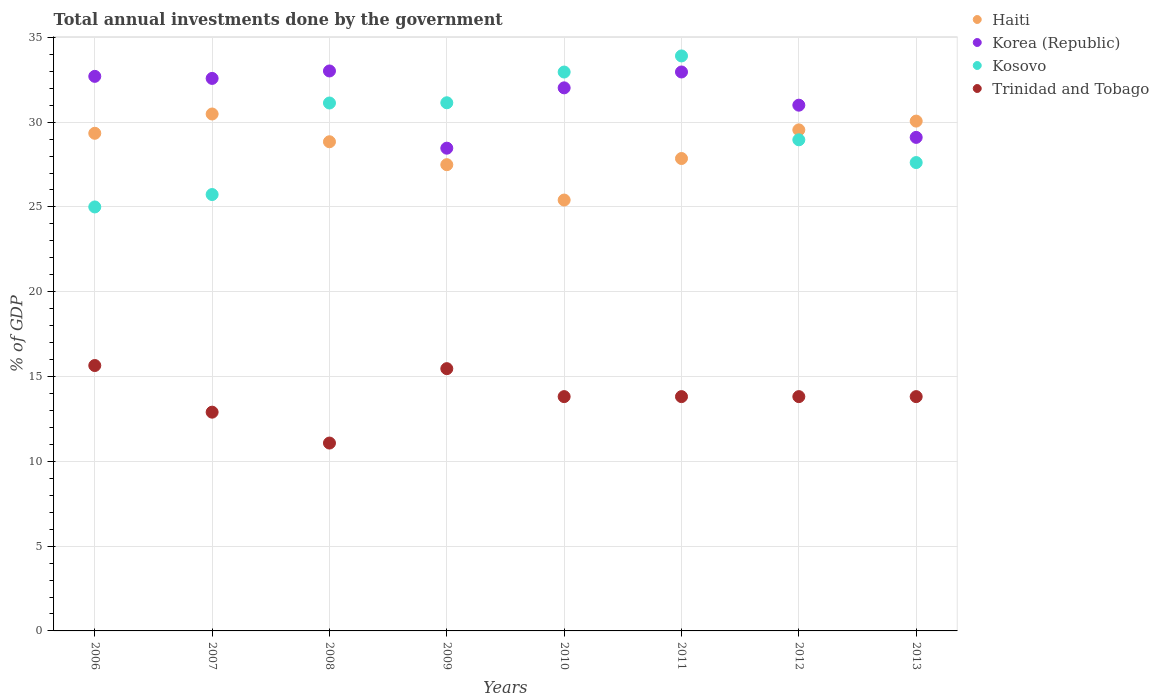Is the number of dotlines equal to the number of legend labels?
Keep it short and to the point. Yes. What is the total annual investments done by the government in Trinidad and Tobago in 2010?
Provide a succinct answer. 13.82. Across all years, what is the maximum total annual investments done by the government in Trinidad and Tobago?
Offer a terse response. 15.65. Across all years, what is the minimum total annual investments done by the government in Trinidad and Tobago?
Your response must be concise. 11.08. In which year was the total annual investments done by the government in Haiti maximum?
Provide a short and direct response. 2007. What is the total total annual investments done by the government in Korea (Republic) in the graph?
Keep it short and to the point. 251.85. What is the difference between the total annual investments done by the government in Trinidad and Tobago in 2010 and that in 2011?
Offer a very short reply. 0. What is the difference between the total annual investments done by the government in Haiti in 2006 and the total annual investments done by the government in Kosovo in 2012?
Make the answer very short. 0.38. What is the average total annual investments done by the government in Korea (Republic) per year?
Give a very brief answer. 31.48. In the year 2007, what is the difference between the total annual investments done by the government in Trinidad and Tobago and total annual investments done by the government in Kosovo?
Ensure brevity in your answer.  -12.83. In how many years, is the total annual investments done by the government in Korea (Republic) greater than 14 %?
Make the answer very short. 8. What is the ratio of the total annual investments done by the government in Korea (Republic) in 2006 to that in 2010?
Make the answer very short. 1.02. What is the difference between the highest and the second highest total annual investments done by the government in Haiti?
Ensure brevity in your answer.  0.42. What is the difference between the highest and the lowest total annual investments done by the government in Trinidad and Tobago?
Provide a succinct answer. 4.57. Does the total annual investments done by the government in Trinidad and Tobago monotonically increase over the years?
Keep it short and to the point. No. How many years are there in the graph?
Give a very brief answer. 8. What is the difference between two consecutive major ticks on the Y-axis?
Offer a very short reply. 5. Are the values on the major ticks of Y-axis written in scientific E-notation?
Offer a terse response. No. Does the graph contain any zero values?
Keep it short and to the point. No. Does the graph contain grids?
Keep it short and to the point. Yes. How many legend labels are there?
Keep it short and to the point. 4. What is the title of the graph?
Give a very brief answer. Total annual investments done by the government. What is the label or title of the Y-axis?
Offer a terse response. % of GDP. What is the % of GDP in Haiti in 2006?
Give a very brief answer. 29.34. What is the % of GDP of Korea (Republic) in 2006?
Ensure brevity in your answer.  32.7. What is the % of GDP in Kosovo in 2006?
Offer a very short reply. 25. What is the % of GDP in Trinidad and Tobago in 2006?
Keep it short and to the point. 15.65. What is the % of GDP in Haiti in 2007?
Make the answer very short. 30.48. What is the % of GDP in Korea (Republic) in 2007?
Provide a succinct answer. 32.58. What is the % of GDP in Kosovo in 2007?
Offer a terse response. 25.73. What is the % of GDP in Trinidad and Tobago in 2007?
Offer a very short reply. 12.9. What is the % of GDP of Haiti in 2008?
Your answer should be compact. 28.84. What is the % of GDP of Korea (Republic) in 2008?
Your answer should be compact. 33.02. What is the % of GDP of Kosovo in 2008?
Give a very brief answer. 31.13. What is the % of GDP in Trinidad and Tobago in 2008?
Provide a short and direct response. 11.08. What is the % of GDP in Haiti in 2009?
Ensure brevity in your answer.  27.49. What is the % of GDP of Korea (Republic) in 2009?
Your response must be concise. 28.47. What is the % of GDP of Kosovo in 2009?
Ensure brevity in your answer.  31.14. What is the % of GDP of Trinidad and Tobago in 2009?
Make the answer very short. 15.46. What is the % of GDP in Haiti in 2010?
Offer a very short reply. 25.41. What is the % of GDP in Korea (Republic) in 2010?
Your answer should be compact. 32.02. What is the % of GDP in Kosovo in 2010?
Offer a very short reply. 32.96. What is the % of GDP of Trinidad and Tobago in 2010?
Keep it short and to the point. 13.82. What is the % of GDP of Haiti in 2011?
Provide a succinct answer. 27.86. What is the % of GDP of Korea (Republic) in 2011?
Make the answer very short. 32.96. What is the % of GDP in Kosovo in 2011?
Give a very brief answer. 33.91. What is the % of GDP in Trinidad and Tobago in 2011?
Keep it short and to the point. 13.82. What is the % of GDP of Haiti in 2012?
Provide a short and direct response. 29.54. What is the % of GDP in Korea (Republic) in 2012?
Offer a terse response. 31. What is the % of GDP in Kosovo in 2012?
Provide a short and direct response. 28.96. What is the % of GDP of Trinidad and Tobago in 2012?
Keep it short and to the point. 13.82. What is the % of GDP in Haiti in 2013?
Ensure brevity in your answer.  30.06. What is the % of GDP of Korea (Republic) in 2013?
Your response must be concise. 29.1. What is the % of GDP in Kosovo in 2013?
Ensure brevity in your answer.  27.62. What is the % of GDP of Trinidad and Tobago in 2013?
Ensure brevity in your answer.  13.82. Across all years, what is the maximum % of GDP in Haiti?
Ensure brevity in your answer.  30.48. Across all years, what is the maximum % of GDP of Korea (Republic)?
Ensure brevity in your answer.  33.02. Across all years, what is the maximum % of GDP in Kosovo?
Your answer should be compact. 33.91. Across all years, what is the maximum % of GDP of Trinidad and Tobago?
Your response must be concise. 15.65. Across all years, what is the minimum % of GDP in Haiti?
Keep it short and to the point. 25.41. Across all years, what is the minimum % of GDP in Korea (Republic)?
Give a very brief answer. 28.47. Across all years, what is the minimum % of GDP in Kosovo?
Offer a terse response. 25. Across all years, what is the minimum % of GDP of Trinidad and Tobago?
Give a very brief answer. 11.08. What is the total % of GDP in Haiti in the graph?
Ensure brevity in your answer.  229.03. What is the total % of GDP of Korea (Republic) in the graph?
Your answer should be very brief. 251.85. What is the total % of GDP in Kosovo in the graph?
Your answer should be very brief. 236.44. What is the total % of GDP of Trinidad and Tobago in the graph?
Give a very brief answer. 110.36. What is the difference between the % of GDP of Haiti in 2006 and that in 2007?
Your answer should be very brief. -1.14. What is the difference between the % of GDP of Korea (Republic) in 2006 and that in 2007?
Your answer should be very brief. 0.12. What is the difference between the % of GDP in Kosovo in 2006 and that in 2007?
Your response must be concise. -0.73. What is the difference between the % of GDP of Trinidad and Tobago in 2006 and that in 2007?
Your answer should be compact. 2.75. What is the difference between the % of GDP of Haiti in 2006 and that in 2008?
Your response must be concise. 0.5. What is the difference between the % of GDP of Korea (Republic) in 2006 and that in 2008?
Offer a terse response. -0.32. What is the difference between the % of GDP of Kosovo in 2006 and that in 2008?
Give a very brief answer. -6.13. What is the difference between the % of GDP of Trinidad and Tobago in 2006 and that in 2008?
Offer a very short reply. 4.57. What is the difference between the % of GDP of Haiti in 2006 and that in 2009?
Keep it short and to the point. 1.85. What is the difference between the % of GDP of Korea (Republic) in 2006 and that in 2009?
Your answer should be compact. 4.24. What is the difference between the % of GDP in Kosovo in 2006 and that in 2009?
Provide a short and direct response. -6.14. What is the difference between the % of GDP in Trinidad and Tobago in 2006 and that in 2009?
Provide a succinct answer. 0.18. What is the difference between the % of GDP of Haiti in 2006 and that in 2010?
Your response must be concise. 3.94. What is the difference between the % of GDP in Korea (Republic) in 2006 and that in 2010?
Your answer should be compact. 0.68. What is the difference between the % of GDP of Kosovo in 2006 and that in 2010?
Your answer should be compact. -7.96. What is the difference between the % of GDP of Trinidad and Tobago in 2006 and that in 2010?
Offer a very short reply. 1.83. What is the difference between the % of GDP of Haiti in 2006 and that in 2011?
Keep it short and to the point. 1.49. What is the difference between the % of GDP in Korea (Republic) in 2006 and that in 2011?
Give a very brief answer. -0.26. What is the difference between the % of GDP of Kosovo in 2006 and that in 2011?
Ensure brevity in your answer.  -8.9. What is the difference between the % of GDP in Trinidad and Tobago in 2006 and that in 2011?
Offer a very short reply. 1.83. What is the difference between the % of GDP in Haiti in 2006 and that in 2012?
Keep it short and to the point. -0.2. What is the difference between the % of GDP of Korea (Republic) in 2006 and that in 2012?
Offer a terse response. 1.7. What is the difference between the % of GDP in Kosovo in 2006 and that in 2012?
Ensure brevity in your answer.  -3.96. What is the difference between the % of GDP in Trinidad and Tobago in 2006 and that in 2012?
Offer a terse response. 1.83. What is the difference between the % of GDP in Haiti in 2006 and that in 2013?
Keep it short and to the point. -0.72. What is the difference between the % of GDP in Korea (Republic) in 2006 and that in 2013?
Your answer should be very brief. 3.6. What is the difference between the % of GDP of Kosovo in 2006 and that in 2013?
Provide a succinct answer. -2.62. What is the difference between the % of GDP of Trinidad and Tobago in 2006 and that in 2013?
Ensure brevity in your answer.  1.83. What is the difference between the % of GDP of Haiti in 2007 and that in 2008?
Keep it short and to the point. 1.64. What is the difference between the % of GDP of Korea (Republic) in 2007 and that in 2008?
Make the answer very short. -0.44. What is the difference between the % of GDP of Kosovo in 2007 and that in 2008?
Give a very brief answer. -5.4. What is the difference between the % of GDP of Trinidad and Tobago in 2007 and that in 2008?
Keep it short and to the point. 1.82. What is the difference between the % of GDP of Haiti in 2007 and that in 2009?
Your answer should be compact. 2.99. What is the difference between the % of GDP in Korea (Republic) in 2007 and that in 2009?
Make the answer very short. 4.11. What is the difference between the % of GDP of Kosovo in 2007 and that in 2009?
Give a very brief answer. -5.41. What is the difference between the % of GDP in Trinidad and Tobago in 2007 and that in 2009?
Your answer should be compact. -2.57. What is the difference between the % of GDP of Haiti in 2007 and that in 2010?
Offer a terse response. 5.07. What is the difference between the % of GDP of Korea (Republic) in 2007 and that in 2010?
Provide a succinct answer. 0.56. What is the difference between the % of GDP in Kosovo in 2007 and that in 2010?
Offer a terse response. -7.22. What is the difference between the % of GDP of Trinidad and Tobago in 2007 and that in 2010?
Offer a terse response. -0.92. What is the difference between the % of GDP of Haiti in 2007 and that in 2011?
Give a very brief answer. 2.62. What is the difference between the % of GDP of Korea (Republic) in 2007 and that in 2011?
Offer a terse response. -0.38. What is the difference between the % of GDP of Kosovo in 2007 and that in 2011?
Make the answer very short. -8.17. What is the difference between the % of GDP of Trinidad and Tobago in 2007 and that in 2011?
Offer a very short reply. -0.92. What is the difference between the % of GDP of Haiti in 2007 and that in 2012?
Your answer should be very brief. 0.94. What is the difference between the % of GDP of Korea (Republic) in 2007 and that in 2012?
Ensure brevity in your answer.  1.58. What is the difference between the % of GDP in Kosovo in 2007 and that in 2012?
Offer a very short reply. -3.23. What is the difference between the % of GDP of Trinidad and Tobago in 2007 and that in 2012?
Offer a very short reply. -0.92. What is the difference between the % of GDP in Haiti in 2007 and that in 2013?
Your answer should be very brief. 0.42. What is the difference between the % of GDP in Korea (Republic) in 2007 and that in 2013?
Give a very brief answer. 3.48. What is the difference between the % of GDP of Kosovo in 2007 and that in 2013?
Provide a short and direct response. -1.89. What is the difference between the % of GDP of Trinidad and Tobago in 2007 and that in 2013?
Provide a short and direct response. -0.92. What is the difference between the % of GDP in Haiti in 2008 and that in 2009?
Provide a short and direct response. 1.35. What is the difference between the % of GDP in Korea (Republic) in 2008 and that in 2009?
Offer a very short reply. 4.55. What is the difference between the % of GDP in Kosovo in 2008 and that in 2009?
Provide a short and direct response. -0.01. What is the difference between the % of GDP of Trinidad and Tobago in 2008 and that in 2009?
Give a very brief answer. -4.39. What is the difference between the % of GDP in Haiti in 2008 and that in 2010?
Offer a very short reply. 3.44. What is the difference between the % of GDP in Kosovo in 2008 and that in 2010?
Provide a short and direct response. -1.83. What is the difference between the % of GDP in Trinidad and Tobago in 2008 and that in 2010?
Offer a very short reply. -2.74. What is the difference between the % of GDP of Haiti in 2008 and that in 2011?
Provide a succinct answer. 0.99. What is the difference between the % of GDP in Korea (Republic) in 2008 and that in 2011?
Your answer should be compact. 0.06. What is the difference between the % of GDP of Kosovo in 2008 and that in 2011?
Your response must be concise. -2.78. What is the difference between the % of GDP in Trinidad and Tobago in 2008 and that in 2011?
Your response must be concise. -2.74. What is the difference between the % of GDP in Haiti in 2008 and that in 2012?
Your answer should be very brief. -0.7. What is the difference between the % of GDP in Korea (Republic) in 2008 and that in 2012?
Your answer should be very brief. 2.02. What is the difference between the % of GDP in Kosovo in 2008 and that in 2012?
Make the answer very short. 2.17. What is the difference between the % of GDP of Trinidad and Tobago in 2008 and that in 2012?
Offer a terse response. -2.74. What is the difference between the % of GDP of Haiti in 2008 and that in 2013?
Offer a very short reply. -1.22. What is the difference between the % of GDP in Korea (Republic) in 2008 and that in 2013?
Provide a short and direct response. 3.92. What is the difference between the % of GDP of Kosovo in 2008 and that in 2013?
Provide a succinct answer. 3.51. What is the difference between the % of GDP of Trinidad and Tobago in 2008 and that in 2013?
Your answer should be compact. -2.74. What is the difference between the % of GDP of Haiti in 2009 and that in 2010?
Give a very brief answer. 2.09. What is the difference between the % of GDP of Korea (Republic) in 2009 and that in 2010?
Keep it short and to the point. -3.56. What is the difference between the % of GDP in Kosovo in 2009 and that in 2010?
Keep it short and to the point. -1.81. What is the difference between the % of GDP of Trinidad and Tobago in 2009 and that in 2010?
Your answer should be compact. 1.65. What is the difference between the % of GDP of Haiti in 2009 and that in 2011?
Your answer should be compact. -0.36. What is the difference between the % of GDP in Korea (Republic) in 2009 and that in 2011?
Provide a succinct answer. -4.49. What is the difference between the % of GDP in Kosovo in 2009 and that in 2011?
Provide a succinct answer. -2.76. What is the difference between the % of GDP of Trinidad and Tobago in 2009 and that in 2011?
Provide a succinct answer. 1.65. What is the difference between the % of GDP in Haiti in 2009 and that in 2012?
Give a very brief answer. -2.05. What is the difference between the % of GDP of Korea (Republic) in 2009 and that in 2012?
Ensure brevity in your answer.  -2.54. What is the difference between the % of GDP in Kosovo in 2009 and that in 2012?
Your response must be concise. 2.18. What is the difference between the % of GDP in Trinidad and Tobago in 2009 and that in 2012?
Make the answer very short. 1.65. What is the difference between the % of GDP of Haiti in 2009 and that in 2013?
Your response must be concise. -2.57. What is the difference between the % of GDP in Korea (Republic) in 2009 and that in 2013?
Provide a succinct answer. -0.64. What is the difference between the % of GDP of Kosovo in 2009 and that in 2013?
Give a very brief answer. 3.53. What is the difference between the % of GDP in Trinidad and Tobago in 2009 and that in 2013?
Give a very brief answer. 1.65. What is the difference between the % of GDP of Haiti in 2010 and that in 2011?
Provide a short and direct response. -2.45. What is the difference between the % of GDP in Korea (Republic) in 2010 and that in 2011?
Your response must be concise. -0.94. What is the difference between the % of GDP of Kosovo in 2010 and that in 2011?
Ensure brevity in your answer.  -0.95. What is the difference between the % of GDP of Trinidad and Tobago in 2010 and that in 2011?
Your answer should be very brief. 0. What is the difference between the % of GDP of Haiti in 2010 and that in 2012?
Provide a succinct answer. -4.14. What is the difference between the % of GDP in Korea (Republic) in 2010 and that in 2012?
Ensure brevity in your answer.  1.02. What is the difference between the % of GDP of Kosovo in 2010 and that in 2012?
Your response must be concise. 4. What is the difference between the % of GDP of Trinidad and Tobago in 2010 and that in 2012?
Make the answer very short. -0. What is the difference between the % of GDP of Haiti in 2010 and that in 2013?
Give a very brief answer. -4.66. What is the difference between the % of GDP of Korea (Republic) in 2010 and that in 2013?
Give a very brief answer. 2.92. What is the difference between the % of GDP in Kosovo in 2010 and that in 2013?
Provide a succinct answer. 5.34. What is the difference between the % of GDP of Haiti in 2011 and that in 2012?
Your answer should be very brief. -1.69. What is the difference between the % of GDP in Korea (Republic) in 2011 and that in 2012?
Make the answer very short. 1.96. What is the difference between the % of GDP in Kosovo in 2011 and that in 2012?
Provide a short and direct response. 4.95. What is the difference between the % of GDP of Trinidad and Tobago in 2011 and that in 2012?
Your answer should be compact. -0. What is the difference between the % of GDP in Haiti in 2011 and that in 2013?
Provide a succinct answer. -2.21. What is the difference between the % of GDP of Korea (Republic) in 2011 and that in 2013?
Offer a very short reply. 3.86. What is the difference between the % of GDP in Kosovo in 2011 and that in 2013?
Give a very brief answer. 6.29. What is the difference between the % of GDP in Trinidad and Tobago in 2011 and that in 2013?
Provide a succinct answer. -0. What is the difference between the % of GDP in Haiti in 2012 and that in 2013?
Keep it short and to the point. -0.52. What is the difference between the % of GDP of Korea (Republic) in 2012 and that in 2013?
Give a very brief answer. 1.9. What is the difference between the % of GDP in Kosovo in 2012 and that in 2013?
Your answer should be compact. 1.34. What is the difference between the % of GDP of Trinidad and Tobago in 2012 and that in 2013?
Your answer should be very brief. 0. What is the difference between the % of GDP of Haiti in 2006 and the % of GDP of Korea (Republic) in 2007?
Ensure brevity in your answer.  -3.24. What is the difference between the % of GDP of Haiti in 2006 and the % of GDP of Kosovo in 2007?
Ensure brevity in your answer.  3.61. What is the difference between the % of GDP of Haiti in 2006 and the % of GDP of Trinidad and Tobago in 2007?
Your answer should be very brief. 16.44. What is the difference between the % of GDP of Korea (Republic) in 2006 and the % of GDP of Kosovo in 2007?
Provide a short and direct response. 6.97. What is the difference between the % of GDP in Korea (Republic) in 2006 and the % of GDP in Trinidad and Tobago in 2007?
Offer a very short reply. 19.8. What is the difference between the % of GDP in Kosovo in 2006 and the % of GDP in Trinidad and Tobago in 2007?
Your answer should be compact. 12.1. What is the difference between the % of GDP of Haiti in 2006 and the % of GDP of Korea (Republic) in 2008?
Offer a terse response. -3.67. What is the difference between the % of GDP of Haiti in 2006 and the % of GDP of Kosovo in 2008?
Your answer should be compact. -1.79. What is the difference between the % of GDP in Haiti in 2006 and the % of GDP in Trinidad and Tobago in 2008?
Your answer should be very brief. 18.27. What is the difference between the % of GDP in Korea (Republic) in 2006 and the % of GDP in Kosovo in 2008?
Make the answer very short. 1.57. What is the difference between the % of GDP in Korea (Republic) in 2006 and the % of GDP in Trinidad and Tobago in 2008?
Offer a very short reply. 21.62. What is the difference between the % of GDP in Kosovo in 2006 and the % of GDP in Trinidad and Tobago in 2008?
Your answer should be compact. 13.92. What is the difference between the % of GDP of Haiti in 2006 and the % of GDP of Korea (Republic) in 2009?
Ensure brevity in your answer.  0.88. What is the difference between the % of GDP in Haiti in 2006 and the % of GDP in Kosovo in 2009?
Ensure brevity in your answer.  -1.8. What is the difference between the % of GDP in Haiti in 2006 and the % of GDP in Trinidad and Tobago in 2009?
Your response must be concise. 13.88. What is the difference between the % of GDP in Korea (Republic) in 2006 and the % of GDP in Kosovo in 2009?
Offer a terse response. 1.56. What is the difference between the % of GDP of Korea (Republic) in 2006 and the % of GDP of Trinidad and Tobago in 2009?
Make the answer very short. 17.24. What is the difference between the % of GDP in Kosovo in 2006 and the % of GDP in Trinidad and Tobago in 2009?
Ensure brevity in your answer.  9.54. What is the difference between the % of GDP of Haiti in 2006 and the % of GDP of Korea (Republic) in 2010?
Give a very brief answer. -2.68. What is the difference between the % of GDP of Haiti in 2006 and the % of GDP of Kosovo in 2010?
Keep it short and to the point. -3.61. What is the difference between the % of GDP in Haiti in 2006 and the % of GDP in Trinidad and Tobago in 2010?
Offer a very short reply. 15.53. What is the difference between the % of GDP in Korea (Republic) in 2006 and the % of GDP in Kosovo in 2010?
Make the answer very short. -0.26. What is the difference between the % of GDP of Korea (Republic) in 2006 and the % of GDP of Trinidad and Tobago in 2010?
Make the answer very short. 18.88. What is the difference between the % of GDP in Kosovo in 2006 and the % of GDP in Trinidad and Tobago in 2010?
Provide a short and direct response. 11.18. What is the difference between the % of GDP in Haiti in 2006 and the % of GDP in Korea (Republic) in 2011?
Keep it short and to the point. -3.62. What is the difference between the % of GDP in Haiti in 2006 and the % of GDP in Kosovo in 2011?
Give a very brief answer. -4.56. What is the difference between the % of GDP in Haiti in 2006 and the % of GDP in Trinidad and Tobago in 2011?
Offer a very short reply. 15.53. What is the difference between the % of GDP in Korea (Republic) in 2006 and the % of GDP in Kosovo in 2011?
Offer a terse response. -1.2. What is the difference between the % of GDP in Korea (Republic) in 2006 and the % of GDP in Trinidad and Tobago in 2011?
Make the answer very short. 18.88. What is the difference between the % of GDP of Kosovo in 2006 and the % of GDP of Trinidad and Tobago in 2011?
Your answer should be compact. 11.18. What is the difference between the % of GDP of Haiti in 2006 and the % of GDP of Korea (Republic) in 2012?
Provide a succinct answer. -1.66. What is the difference between the % of GDP of Haiti in 2006 and the % of GDP of Kosovo in 2012?
Your answer should be very brief. 0.38. What is the difference between the % of GDP of Haiti in 2006 and the % of GDP of Trinidad and Tobago in 2012?
Ensure brevity in your answer.  15.53. What is the difference between the % of GDP of Korea (Republic) in 2006 and the % of GDP of Kosovo in 2012?
Make the answer very short. 3.74. What is the difference between the % of GDP in Korea (Republic) in 2006 and the % of GDP in Trinidad and Tobago in 2012?
Your response must be concise. 18.88. What is the difference between the % of GDP of Kosovo in 2006 and the % of GDP of Trinidad and Tobago in 2012?
Provide a succinct answer. 11.18. What is the difference between the % of GDP of Haiti in 2006 and the % of GDP of Korea (Republic) in 2013?
Make the answer very short. 0.24. What is the difference between the % of GDP in Haiti in 2006 and the % of GDP in Kosovo in 2013?
Ensure brevity in your answer.  1.73. What is the difference between the % of GDP of Haiti in 2006 and the % of GDP of Trinidad and Tobago in 2013?
Give a very brief answer. 15.53. What is the difference between the % of GDP of Korea (Republic) in 2006 and the % of GDP of Kosovo in 2013?
Keep it short and to the point. 5.08. What is the difference between the % of GDP in Korea (Republic) in 2006 and the % of GDP in Trinidad and Tobago in 2013?
Make the answer very short. 18.88. What is the difference between the % of GDP in Kosovo in 2006 and the % of GDP in Trinidad and Tobago in 2013?
Make the answer very short. 11.18. What is the difference between the % of GDP in Haiti in 2007 and the % of GDP in Korea (Republic) in 2008?
Make the answer very short. -2.54. What is the difference between the % of GDP in Haiti in 2007 and the % of GDP in Kosovo in 2008?
Make the answer very short. -0.65. What is the difference between the % of GDP in Haiti in 2007 and the % of GDP in Trinidad and Tobago in 2008?
Provide a short and direct response. 19.4. What is the difference between the % of GDP in Korea (Republic) in 2007 and the % of GDP in Kosovo in 2008?
Make the answer very short. 1.45. What is the difference between the % of GDP in Korea (Republic) in 2007 and the % of GDP in Trinidad and Tobago in 2008?
Your answer should be compact. 21.5. What is the difference between the % of GDP of Kosovo in 2007 and the % of GDP of Trinidad and Tobago in 2008?
Your answer should be compact. 14.65. What is the difference between the % of GDP in Haiti in 2007 and the % of GDP in Korea (Republic) in 2009?
Offer a terse response. 2.02. What is the difference between the % of GDP of Haiti in 2007 and the % of GDP of Kosovo in 2009?
Offer a terse response. -0.66. What is the difference between the % of GDP of Haiti in 2007 and the % of GDP of Trinidad and Tobago in 2009?
Provide a succinct answer. 15.02. What is the difference between the % of GDP in Korea (Republic) in 2007 and the % of GDP in Kosovo in 2009?
Your answer should be compact. 1.44. What is the difference between the % of GDP of Korea (Republic) in 2007 and the % of GDP of Trinidad and Tobago in 2009?
Your answer should be very brief. 17.11. What is the difference between the % of GDP of Kosovo in 2007 and the % of GDP of Trinidad and Tobago in 2009?
Your response must be concise. 10.27. What is the difference between the % of GDP in Haiti in 2007 and the % of GDP in Korea (Republic) in 2010?
Ensure brevity in your answer.  -1.54. What is the difference between the % of GDP of Haiti in 2007 and the % of GDP of Kosovo in 2010?
Keep it short and to the point. -2.47. What is the difference between the % of GDP of Haiti in 2007 and the % of GDP of Trinidad and Tobago in 2010?
Your answer should be compact. 16.66. What is the difference between the % of GDP in Korea (Republic) in 2007 and the % of GDP in Kosovo in 2010?
Give a very brief answer. -0.38. What is the difference between the % of GDP of Korea (Republic) in 2007 and the % of GDP of Trinidad and Tobago in 2010?
Your answer should be very brief. 18.76. What is the difference between the % of GDP in Kosovo in 2007 and the % of GDP in Trinidad and Tobago in 2010?
Keep it short and to the point. 11.92. What is the difference between the % of GDP in Haiti in 2007 and the % of GDP in Korea (Republic) in 2011?
Offer a terse response. -2.48. What is the difference between the % of GDP in Haiti in 2007 and the % of GDP in Kosovo in 2011?
Your answer should be very brief. -3.42. What is the difference between the % of GDP in Haiti in 2007 and the % of GDP in Trinidad and Tobago in 2011?
Your response must be concise. 16.67. What is the difference between the % of GDP in Korea (Republic) in 2007 and the % of GDP in Kosovo in 2011?
Your response must be concise. -1.33. What is the difference between the % of GDP in Korea (Republic) in 2007 and the % of GDP in Trinidad and Tobago in 2011?
Your response must be concise. 18.76. What is the difference between the % of GDP in Kosovo in 2007 and the % of GDP in Trinidad and Tobago in 2011?
Your answer should be very brief. 11.92. What is the difference between the % of GDP in Haiti in 2007 and the % of GDP in Korea (Republic) in 2012?
Offer a very short reply. -0.52. What is the difference between the % of GDP of Haiti in 2007 and the % of GDP of Kosovo in 2012?
Provide a succinct answer. 1.52. What is the difference between the % of GDP in Haiti in 2007 and the % of GDP in Trinidad and Tobago in 2012?
Make the answer very short. 16.66. What is the difference between the % of GDP of Korea (Republic) in 2007 and the % of GDP of Kosovo in 2012?
Your answer should be very brief. 3.62. What is the difference between the % of GDP of Korea (Republic) in 2007 and the % of GDP of Trinidad and Tobago in 2012?
Make the answer very short. 18.76. What is the difference between the % of GDP in Kosovo in 2007 and the % of GDP in Trinidad and Tobago in 2012?
Provide a short and direct response. 11.92. What is the difference between the % of GDP of Haiti in 2007 and the % of GDP of Korea (Republic) in 2013?
Your response must be concise. 1.38. What is the difference between the % of GDP of Haiti in 2007 and the % of GDP of Kosovo in 2013?
Make the answer very short. 2.86. What is the difference between the % of GDP in Haiti in 2007 and the % of GDP in Trinidad and Tobago in 2013?
Provide a short and direct response. 16.67. What is the difference between the % of GDP of Korea (Republic) in 2007 and the % of GDP of Kosovo in 2013?
Keep it short and to the point. 4.96. What is the difference between the % of GDP in Korea (Republic) in 2007 and the % of GDP in Trinidad and Tobago in 2013?
Provide a short and direct response. 18.76. What is the difference between the % of GDP in Kosovo in 2007 and the % of GDP in Trinidad and Tobago in 2013?
Your answer should be compact. 11.92. What is the difference between the % of GDP in Haiti in 2008 and the % of GDP in Korea (Republic) in 2009?
Provide a short and direct response. 0.38. What is the difference between the % of GDP in Haiti in 2008 and the % of GDP in Kosovo in 2009?
Your answer should be compact. -2.3. What is the difference between the % of GDP of Haiti in 2008 and the % of GDP of Trinidad and Tobago in 2009?
Provide a succinct answer. 13.38. What is the difference between the % of GDP of Korea (Republic) in 2008 and the % of GDP of Kosovo in 2009?
Ensure brevity in your answer.  1.87. What is the difference between the % of GDP of Korea (Republic) in 2008 and the % of GDP of Trinidad and Tobago in 2009?
Provide a succinct answer. 17.55. What is the difference between the % of GDP of Kosovo in 2008 and the % of GDP of Trinidad and Tobago in 2009?
Make the answer very short. 15.66. What is the difference between the % of GDP of Haiti in 2008 and the % of GDP of Korea (Republic) in 2010?
Keep it short and to the point. -3.18. What is the difference between the % of GDP in Haiti in 2008 and the % of GDP in Kosovo in 2010?
Your answer should be very brief. -4.11. What is the difference between the % of GDP of Haiti in 2008 and the % of GDP of Trinidad and Tobago in 2010?
Your answer should be very brief. 15.03. What is the difference between the % of GDP of Korea (Republic) in 2008 and the % of GDP of Kosovo in 2010?
Offer a terse response. 0.06. What is the difference between the % of GDP in Korea (Republic) in 2008 and the % of GDP in Trinidad and Tobago in 2010?
Offer a very short reply. 19.2. What is the difference between the % of GDP of Kosovo in 2008 and the % of GDP of Trinidad and Tobago in 2010?
Your response must be concise. 17.31. What is the difference between the % of GDP in Haiti in 2008 and the % of GDP in Korea (Republic) in 2011?
Give a very brief answer. -4.11. What is the difference between the % of GDP of Haiti in 2008 and the % of GDP of Kosovo in 2011?
Keep it short and to the point. -5.06. What is the difference between the % of GDP of Haiti in 2008 and the % of GDP of Trinidad and Tobago in 2011?
Offer a very short reply. 15.03. What is the difference between the % of GDP in Korea (Republic) in 2008 and the % of GDP in Kosovo in 2011?
Keep it short and to the point. -0.89. What is the difference between the % of GDP in Korea (Republic) in 2008 and the % of GDP in Trinidad and Tobago in 2011?
Offer a very short reply. 19.2. What is the difference between the % of GDP in Kosovo in 2008 and the % of GDP in Trinidad and Tobago in 2011?
Give a very brief answer. 17.31. What is the difference between the % of GDP in Haiti in 2008 and the % of GDP in Korea (Republic) in 2012?
Your answer should be compact. -2.16. What is the difference between the % of GDP in Haiti in 2008 and the % of GDP in Kosovo in 2012?
Give a very brief answer. -0.11. What is the difference between the % of GDP in Haiti in 2008 and the % of GDP in Trinidad and Tobago in 2012?
Provide a short and direct response. 15.03. What is the difference between the % of GDP in Korea (Republic) in 2008 and the % of GDP in Kosovo in 2012?
Your answer should be very brief. 4.06. What is the difference between the % of GDP in Korea (Republic) in 2008 and the % of GDP in Trinidad and Tobago in 2012?
Provide a short and direct response. 19.2. What is the difference between the % of GDP of Kosovo in 2008 and the % of GDP of Trinidad and Tobago in 2012?
Your response must be concise. 17.31. What is the difference between the % of GDP of Haiti in 2008 and the % of GDP of Korea (Republic) in 2013?
Your answer should be compact. -0.26. What is the difference between the % of GDP of Haiti in 2008 and the % of GDP of Kosovo in 2013?
Ensure brevity in your answer.  1.23. What is the difference between the % of GDP in Haiti in 2008 and the % of GDP in Trinidad and Tobago in 2013?
Make the answer very short. 15.03. What is the difference between the % of GDP in Korea (Republic) in 2008 and the % of GDP in Kosovo in 2013?
Ensure brevity in your answer.  5.4. What is the difference between the % of GDP of Korea (Republic) in 2008 and the % of GDP of Trinidad and Tobago in 2013?
Offer a very short reply. 19.2. What is the difference between the % of GDP of Kosovo in 2008 and the % of GDP of Trinidad and Tobago in 2013?
Your response must be concise. 17.31. What is the difference between the % of GDP of Haiti in 2009 and the % of GDP of Korea (Republic) in 2010?
Your response must be concise. -4.53. What is the difference between the % of GDP of Haiti in 2009 and the % of GDP of Kosovo in 2010?
Keep it short and to the point. -5.46. What is the difference between the % of GDP in Haiti in 2009 and the % of GDP in Trinidad and Tobago in 2010?
Provide a short and direct response. 13.68. What is the difference between the % of GDP in Korea (Republic) in 2009 and the % of GDP in Kosovo in 2010?
Provide a succinct answer. -4.49. What is the difference between the % of GDP in Korea (Republic) in 2009 and the % of GDP in Trinidad and Tobago in 2010?
Provide a short and direct response. 14.65. What is the difference between the % of GDP of Kosovo in 2009 and the % of GDP of Trinidad and Tobago in 2010?
Ensure brevity in your answer.  17.33. What is the difference between the % of GDP in Haiti in 2009 and the % of GDP in Korea (Republic) in 2011?
Provide a succinct answer. -5.47. What is the difference between the % of GDP of Haiti in 2009 and the % of GDP of Kosovo in 2011?
Ensure brevity in your answer.  -6.41. What is the difference between the % of GDP in Haiti in 2009 and the % of GDP in Trinidad and Tobago in 2011?
Keep it short and to the point. 13.68. What is the difference between the % of GDP of Korea (Republic) in 2009 and the % of GDP of Kosovo in 2011?
Your answer should be compact. -5.44. What is the difference between the % of GDP of Korea (Republic) in 2009 and the % of GDP of Trinidad and Tobago in 2011?
Keep it short and to the point. 14.65. What is the difference between the % of GDP of Kosovo in 2009 and the % of GDP of Trinidad and Tobago in 2011?
Provide a short and direct response. 17.33. What is the difference between the % of GDP of Haiti in 2009 and the % of GDP of Korea (Republic) in 2012?
Provide a short and direct response. -3.51. What is the difference between the % of GDP of Haiti in 2009 and the % of GDP of Kosovo in 2012?
Keep it short and to the point. -1.47. What is the difference between the % of GDP in Haiti in 2009 and the % of GDP in Trinidad and Tobago in 2012?
Your answer should be compact. 13.68. What is the difference between the % of GDP in Korea (Republic) in 2009 and the % of GDP in Kosovo in 2012?
Your response must be concise. -0.49. What is the difference between the % of GDP of Korea (Republic) in 2009 and the % of GDP of Trinidad and Tobago in 2012?
Your answer should be very brief. 14.65. What is the difference between the % of GDP in Kosovo in 2009 and the % of GDP in Trinidad and Tobago in 2012?
Keep it short and to the point. 17.33. What is the difference between the % of GDP of Haiti in 2009 and the % of GDP of Korea (Republic) in 2013?
Provide a succinct answer. -1.61. What is the difference between the % of GDP of Haiti in 2009 and the % of GDP of Kosovo in 2013?
Keep it short and to the point. -0.13. What is the difference between the % of GDP of Haiti in 2009 and the % of GDP of Trinidad and Tobago in 2013?
Make the answer very short. 13.68. What is the difference between the % of GDP in Korea (Republic) in 2009 and the % of GDP in Kosovo in 2013?
Give a very brief answer. 0.85. What is the difference between the % of GDP of Korea (Republic) in 2009 and the % of GDP of Trinidad and Tobago in 2013?
Give a very brief answer. 14.65. What is the difference between the % of GDP of Kosovo in 2009 and the % of GDP of Trinidad and Tobago in 2013?
Provide a short and direct response. 17.33. What is the difference between the % of GDP in Haiti in 2010 and the % of GDP in Korea (Republic) in 2011?
Give a very brief answer. -7.55. What is the difference between the % of GDP in Haiti in 2010 and the % of GDP in Kosovo in 2011?
Ensure brevity in your answer.  -8.5. What is the difference between the % of GDP of Haiti in 2010 and the % of GDP of Trinidad and Tobago in 2011?
Ensure brevity in your answer.  11.59. What is the difference between the % of GDP of Korea (Republic) in 2010 and the % of GDP of Kosovo in 2011?
Offer a very short reply. -1.88. What is the difference between the % of GDP in Korea (Republic) in 2010 and the % of GDP in Trinidad and Tobago in 2011?
Offer a very short reply. 18.21. What is the difference between the % of GDP in Kosovo in 2010 and the % of GDP in Trinidad and Tobago in 2011?
Offer a very short reply. 19.14. What is the difference between the % of GDP in Haiti in 2010 and the % of GDP in Korea (Republic) in 2012?
Give a very brief answer. -5.59. What is the difference between the % of GDP of Haiti in 2010 and the % of GDP of Kosovo in 2012?
Make the answer very short. -3.55. What is the difference between the % of GDP in Haiti in 2010 and the % of GDP in Trinidad and Tobago in 2012?
Keep it short and to the point. 11.59. What is the difference between the % of GDP of Korea (Republic) in 2010 and the % of GDP of Kosovo in 2012?
Offer a very short reply. 3.06. What is the difference between the % of GDP of Korea (Republic) in 2010 and the % of GDP of Trinidad and Tobago in 2012?
Offer a terse response. 18.21. What is the difference between the % of GDP of Kosovo in 2010 and the % of GDP of Trinidad and Tobago in 2012?
Your response must be concise. 19.14. What is the difference between the % of GDP of Haiti in 2010 and the % of GDP of Korea (Republic) in 2013?
Provide a short and direct response. -3.69. What is the difference between the % of GDP in Haiti in 2010 and the % of GDP in Kosovo in 2013?
Give a very brief answer. -2.21. What is the difference between the % of GDP of Haiti in 2010 and the % of GDP of Trinidad and Tobago in 2013?
Your answer should be compact. 11.59. What is the difference between the % of GDP in Korea (Republic) in 2010 and the % of GDP in Kosovo in 2013?
Your answer should be compact. 4.41. What is the difference between the % of GDP in Korea (Republic) in 2010 and the % of GDP in Trinidad and Tobago in 2013?
Give a very brief answer. 18.21. What is the difference between the % of GDP in Kosovo in 2010 and the % of GDP in Trinidad and Tobago in 2013?
Make the answer very short. 19.14. What is the difference between the % of GDP of Haiti in 2011 and the % of GDP of Korea (Republic) in 2012?
Offer a very short reply. -3.14. What is the difference between the % of GDP of Haiti in 2011 and the % of GDP of Kosovo in 2012?
Ensure brevity in your answer.  -1.1. What is the difference between the % of GDP of Haiti in 2011 and the % of GDP of Trinidad and Tobago in 2012?
Make the answer very short. 14.04. What is the difference between the % of GDP of Korea (Republic) in 2011 and the % of GDP of Kosovo in 2012?
Your answer should be compact. 4. What is the difference between the % of GDP in Korea (Republic) in 2011 and the % of GDP in Trinidad and Tobago in 2012?
Make the answer very short. 19.14. What is the difference between the % of GDP in Kosovo in 2011 and the % of GDP in Trinidad and Tobago in 2012?
Ensure brevity in your answer.  20.09. What is the difference between the % of GDP in Haiti in 2011 and the % of GDP in Korea (Republic) in 2013?
Your answer should be compact. -1.25. What is the difference between the % of GDP of Haiti in 2011 and the % of GDP of Kosovo in 2013?
Ensure brevity in your answer.  0.24. What is the difference between the % of GDP in Haiti in 2011 and the % of GDP in Trinidad and Tobago in 2013?
Your response must be concise. 14.04. What is the difference between the % of GDP in Korea (Republic) in 2011 and the % of GDP in Kosovo in 2013?
Ensure brevity in your answer.  5.34. What is the difference between the % of GDP in Korea (Republic) in 2011 and the % of GDP in Trinidad and Tobago in 2013?
Offer a very short reply. 19.14. What is the difference between the % of GDP in Kosovo in 2011 and the % of GDP in Trinidad and Tobago in 2013?
Offer a very short reply. 20.09. What is the difference between the % of GDP of Haiti in 2012 and the % of GDP of Korea (Republic) in 2013?
Keep it short and to the point. 0.44. What is the difference between the % of GDP in Haiti in 2012 and the % of GDP in Kosovo in 2013?
Make the answer very short. 1.93. What is the difference between the % of GDP in Haiti in 2012 and the % of GDP in Trinidad and Tobago in 2013?
Your answer should be compact. 15.73. What is the difference between the % of GDP in Korea (Republic) in 2012 and the % of GDP in Kosovo in 2013?
Make the answer very short. 3.38. What is the difference between the % of GDP in Korea (Republic) in 2012 and the % of GDP in Trinidad and Tobago in 2013?
Your answer should be very brief. 17.19. What is the difference between the % of GDP of Kosovo in 2012 and the % of GDP of Trinidad and Tobago in 2013?
Your answer should be compact. 15.14. What is the average % of GDP of Haiti per year?
Provide a short and direct response. 28.63. What is the average % of GDP in Korea (Republic) per year?
Offer a very short reply. 31.48. What is the average % of GDP of Kosovo per year?
Make the answer very short. 29.56. What is the average % of GDP in Trinidad and Tobago per year?
Make the answer very short. 13.79. In the year 2006, what is the difference between the % of GDP of Haiti and % of GDP of Korea (Republic)?
Your answer should be very brief. -3.36. In the year 2006, what is the difference between the % of GDP in Haiti and % of GDP in Kosovo?
Your response must be concise. 4.34. In the year 2006, what is the difference between the % of GDP in Haiti and % of GDP in Trinidad and Tobago?
Offer a terse response. 13.69. In the year 2006, what is the difference between the % of GDP in Korea (Republic) and % of GDP in Kosovo?
Your answer should be very brief. 7.7. In the year 2006, what is the difference between the % of GDP in Korea (Republic) and % of GDP in Trinidad and Tobago?
Your answer should be very brief. 17.05. In the year 2006, what is the difference between the % of GDP of Kosovo and % of GDP of Trinidad and Tobago?
Your answer should be compact. 9.35. In the year 2007, what is the difference between the % of GDP in Haiti and % of GDP in Korea (Republic)?
Make the answer very short. -2.1. In the year 2007, what is the difference between the % of GDP in Haiti and % of GDP in Kosovo?
Your answer should be compact. 4.75. In the year 2007, what is the difference between the % of GDP of Haiti and % of GDP of Trinidad and Tobago?
Your answer should be very brief. 17.58. In the year 2007, what is the difference between the % of GDP in Korea (Republic) and % of GDP in Kosovo?
Your answer should be compact. 6.85. In the year 2007, what is the difference between the % of GDP of Korea (Republic) and % of GDP of Trinidad and Tobago?
Your response must be concise. 19.68. In the year 2007, what is the difference between the % of GDP in Kosovo and % of GDP in Trinidad and Tobago?
Make the answer very short. 12.83. In the year 2008, what is the difference between the % of GDP of Haiti and % of GDP of Korea (Republic)?
Make the answer very short. -4.17. In the year 2008, what is the difference between the % of GDP of Haiti and % of GDP of Kosovo?
Give a very brief answer. -2.29. In the year 2008, what is the difference between the % of GDP in Haiti and % of GDP in Trinidad and Tobago?
Provide a succinct answer. 17.77. In the year 2008, what is the difference between the % of GDP in Korea (Republic) and % of GDP in Kosovo?
Provide a short and direct response. 1.89. In the year 2008, what is the difference between the % of GDP in Korea (Republic) and % of GDP in Trinidad and Tobago?
Your answer should be very brief. 21.94. In the year 2008, what is the difference between the % of GDP in Kosovo and % of GDP in Trinidad and Tobago?
Provide a short and direct response. 20.05. In the year 2009, what is the difference between the % of GDP of Haiti and % of GDP of Korea (Republic)?
Keep it short and to the point. -0.97. In the year 2009, what is the difference between the % of GDP of Haiti and % of GDP of Kosovo?
Your answer should be compact. -3.65. In the year 2009, what is the difference between the % of GDP of Haiti and % of GDP of Trinidad and Tobago?
Offer a very short reply. 12.03. In the year 2009, what is the difference between the % of GDP of Korea (Republic) and % of GDP of Kosovo?
Ensure brevity in your answer.  -2.68. In the year 2009, what is the difference between the % of GDP in Korea (Republic) and % of GDP in Trinidad and Tobago?
Your answer should be very brief. 13. In the year 2009, what is the difference between the % of GDP in Kosovo and % of GDP in Trinidad and Tobago?
Offer a terse response. 15.68. In the year 2010, what is the difference between the % of GDP in Haiti and % of GDP in Korea (Republic)?
Offer a very short reply. -6.62. In the year 2010, what is the difference between the % of GDP of Haiti and % of GDP of Kosovo?
Give a very brief answer. -7.55. In the year 2010, what is the difference between the % of GDP of Haiti and % of GDP of Trinidad and Tobago?
Your answer should be compact. 11.59. In the year 2010, what is the difference between the % of GDP in Korea (Republic) and % of GDP in Kosovo?
Offer a very short reply. -0.93. In the year 2010, what is the difference between the % of GDP of Korea (Republic) and % of GDP of Trinidad and Tobago?
Offer a terse response. 18.21. In the year 2010, what is the difference between the % of GDP in Kosovo and % of GDP in Trinidad and Tobago?
Your answer should be compact. 19.14. In the year 2011, what is the difference between the % of GDP of Haiti and % of GDP of Korea (Republic)?
Provide a succinct answer. -5.1. In the year 2011, what is the difference between the % of GDP of Haiti and % of GDP of Kosovo?
Offer a terse response. -6.05. In the year 2011, what is the difference between the % of GDP of Haiti and % of GDP of Trinidad and Tobago?
Your response must be concise. 14.04. In the year 2011, what is the difference between the % of GDP of Korea (Republic) and % of GDP of Kosovo?
Give a very brief answer. -0.95. In the year 2011, what is the difference between the % of GDP of Korea (Republic) and % of GDP of Trinidad and Tobago?
Keep it short and to the point. 19.14. In the year 2011, what is the difference between the % of GDP of Kosovo and % of GDP of Trinidad and Tobago?
Your response must be concise. 20.09. In the year 2012, what is the difference between the % of GDP of Haiti and % of GDP of Korea (Republic)?
Offer a very short reply. -1.46. In the year 2012, what is the difference between the % of GDP in Haiti and % of GDP in Kosovo?
Provide a short and direct response. 0.59. In the year 2012, what is the difference between the % of GDP of Haiti and % of GDP of Trinidad and Tobago?
Your answer should be compact. 15.73. In the year 2012, what is the difference between the % of GDP of Korea (Republic) and % of GDP of Kosovo?
Offer a terse response. 2.04. In the year 2012, what is the difference between the % of GDP of Korea (Republic) and % of GDP of Trinidad and Tobago?
Make the answer very short. 17.18. In the year 2012, what is the difference between the % of GDP in Kosovo and % of GDP in Trinidad and Tobago?
Provide a succinct answer. 15.14. In the year 2013, what is the difference between the % of GDP in Haiti and % of GDP in Korea (Republic)?
Your answer should be compact. 0.96. In the year 2013, what is the difference between the % of GDP in Haiti and % of GDP in Kosovo?
Provide a short and direct response. 2.44. In the year 2013, what is the difference between the % of GDP of Haiti and % of GDP of Trinidad and Tobago?
Provide a short and direct response. 16.25. In the year 2013, what is the difference between the % of GDP of Korea (Republic) and % of GDP of Kosovo?
Your answer should be very brief. 1.48. In the year 2013, what is the difference between the % of GDP in Korea (Republic) and % of GDP in Trinidad and Tobago?
Provide a succinct answer. 15.29. In the year 2013, what is the difference between the % of GDP in Kosovo and % of GDP in Trinidad and Tobago?
Offer a very short reply. 13.8. What is the ratio of the % of GDP in Haiti in 2006 to that in 2007?
Your answer should be very brief. 0.96. What is the ratio of the % of GDP of Kosovo in 2006 to that in 2007?
Give a very brief answer. 0.97. What is the ratio of the % of GDP in Trinidad and Tobago in 2006 to that in 2007?
Offer a terse response. 1.21. What is the ratio of the % of GDP in Haiti in 2006 to that in 2008?
Provide a succinct answer. 1.02. What is the ratio of the % of GDP in Kosovo in 2006 to that in 2008?
Keep it short and to the point. 0.8. What is the ratio of the % of GDP of Trinidad and Tobago in 2006 to that in 2008?
Ensure brevity in your answer.  1.41. What is the ratio of the % of GDP in Haiti in 2006 to that in 2009?
Your response must be concise. 1.07. What is the ratio of the % of GDP of Korea (Republic) in 2006 to that in 2009?
Provide a succinct answer. 1.15. What is the ratio of the % of GDP of Kosovo in 2006 to that in 2009?
Keep it short and to the point. 0.8. What is the ratio of the % of GDP of Trinidad and Tobago in 2006 to that in 2009?
Keep it short and to the point. 1.01. What is the ratio of the % of GDP of Haiti in 2006 to that in 2010?
Provide a succinct answer. 1.15. What is the ratio of the % of GDP in Korea (Republic) in 2006 to that in 2010?
Your answer should be compact. 1.02. What is the ratio of the % of GDP in Kosovo in 2006 to that in 2010?
Provide a short and direct response. 0.76. What is the ratio of the % of GDP in Trinidad and Tobago in 2006 to that in 2010?
Your answer should be compact. 1.13. What is the ratio of the % of GDP of Haiti in 2006 to that in 2011?
Keep it short and to the point. 1.05. What is the ratio of the % of GDP of Korea (Republic) in 2006 to that in 2011?
Give a very brief answer. 0.99. What is the ratio of the % of GDP of Kosovo in 2006 to that in 2011?
Your answer should be compact. 0.74. What is the ratio of the % of GDP of Trinidad and Tobago in 2006 to that in 2011?
Give a very brief answer. 1.13. What is the ratio of the % of GDP in Haiti in 2006 to that in 2012?
Offer a terse response. 0.99. What is the ratio of the % of GDP of Korea (Republic) in 2006 to that in 2012?
Keep it short and to the point. 1.05. What is the ratio of the % of GDP of Kosovo in 2006 to that in 2012?
Your response must be concise. 0.86. What is the ratio of the % of GDP in Trinidad and Tobago in 2006 to that in 2012?
Give a very brief answer. 1.13. What is the ratio of the % of GDP in Haiti in 2006 to that in 2013?
Offer a terse response. 0.98. What is the ratio of the % of GDP in Korea (Republic) in 2006 to that in 2013?
Keep it short and to the point. 1.12. What is the ratio of the % of GDP of Kosovo in 2006 to that in 2013?
Make the answer very short. 0.91. What is the ratio of the % of GDP in Trinidad and Tobago in 2006 to that in 2013?
Your answer should be compact. 1.13. What is the ratio of the % of GDP in Haiti in 2007 to that in 2008?
Provide a short and direct response. 1.06. What is the ratio of the % of GDP of Korea (Republic) in 2007 to that in 2008?
Offer a terse response. 0.99. What is the ratio of the % of GDP of Kosovo in 2007 to that in 2008?
Offer a very short reply. 0.83. What is the ratio of the % of GDP of Trinidad and Tobago in 2007 to that in 2008?
Make the answer very short. 1.16. What is the ratio of the % of GDP in Haiti in 2007 to that in 2009?
Keep it short and to the point. 1.11. What is the ratio of the % of GDP in Korea (Republic) in 2007 to that in 2009?
Offer a terse response. 1.14. What is the ratio of the % of GDP of Kosovo in 2007 to that in 2009?
Your response must be concise. 0.83. What is the ratio of the % of GDP in Trinidad and Tobago in 2007 to that in 2009?
Offer a very short reply. 0.83. What is the ratio of the % of GDP of Haiti in 2007 to that in 2010?
Provide a short and direct response. 1.2. What is the ratio of the % of GDP of Korea (Republic) in 2007 to that in 2010?
Offer a terse response. 1.02. What is the ratio of the % of GDP in Kosovo in 2007 to that in 2010?
Offer a very short reply. 0.78. What is the ratio of the % of GDP of Trinidad and Tobago in 2007 to that in 2010?
Give a very brief answer. 0.93. What is the ratio of the % of GDP in Haiti in 2007 to that in 2011?
Provide a succinct answer. 1.09. What is the ratio of the % of GDP in Kosovo in 2007 to that in 2011?
Give a very brief answer. 0.76. What is the ratio of the % of GDP of Trinidad and Tobago in 2007 to that in 2011?
Ensure brevity in your answer.  0.93. What is the ratio of the % of GDP of Haiti in 2007 to that in 2012?
Give a very brief answer. 1.03. What is the ratio of the % of GDP of Korea (Republic) in 2007 to that in 2012?
Provide a succinct answer. 1.05. What is the ratio of the % of GDP of Kosovo in 2007 to that in 2012?
Your answer should be compact. 0.89. What is the ratio of the % of GDP in Trinidad and Tobago in 2007 to that in 2012?
Ensure brevity in your answer.  0.93. What is the ratio of the % of GDP in Haiti in 2007 to that in 2013?
Provide a short and direct response. 1.01. What is the ratio of the % of GDP of Korea (Republic) in 2007 to that in 2013?
Give a very brief answer. 1.12. What is the ratio of the % of GDP in Kosovo in 2007 to that in 2013?
Ensure brevity in your answer.  0.93. What is the ratio of the % of GDP of Trinidad and Tobago in 2007 to that in 2013?
Offer a terse response. 0.93. What is the ratio of the % of GDP in Haiti in 2008 to that in 2009?
Give a very brief answer. 1.05. What is the ratio of the % of GDP of Korea (Republic) in 2008 to that in 2009?
Provide a short and direct response. 1.16. What is the ratio of the % of GDP in Trinidad and Tobago in 2008 to that in 2009?
Offer a terse response. 0.72. What is the ratio of the % of GDP of Haiti in 2008 to that in 2010?
Offer a terse response. 1.14. What is the ratio of the % of GDP in Korea (Republic) in 2008 to that in 2010?
Your answer should be compact. 1.03. What is the ratio of the % of GDP of Kosovo in 2008 to that in 2010?
Offer a very short reply. 0.94. What is the ratio of the % of GDP in Trinidad and Tobago in 2008 to that in 2010?
Keep it short and to the point. 0.8. What is the ratio of the % of GDP of Haiti in 2008 to that in 2011?
Make the answer very short. 1.04. What is the ratio of the % of GDP of Kosovo in 2008 to that in 2011?
Provide a succinct answer. 0.92. What is the ratio of the % of GDP in Trinidad and Tobago in 2008 to that in 2011?
Your answer should be compact. 0.8. What is the ratio of the % of GDP of Haiti in 2008 to that in 2012?
Make the answer very short. 0.98. What is the ratio of the % of GDP in Korea (Republic) in 2008 to that in 2012?
Provide a short and direct response. 1.07. What is the ratio of the % of GDP of Kosovo in 2008 to that in 2012?
Your answer should be very brief. 1.07. What is the ratio of the % of GDP in Trinidad and Tobago in 2008 to that in 2012?
Provide a short and direct response. 0.8. What is the ratio of the % of GDP of Haiti in 2008 to that in 2013?
Keep it short and to the point. 0.96. What is the ratio of the % of GDP of Korea (Republic) in 2008 to that in 2013?
Your response must be concise. 1.13. What is the ratio of the % of GDP of Kosovo in 2008 to that in 2013?
Make the answer very short. 1.13. What is the ratio of the % of GDP of Trinidad and Tobago in 2008 to that in 2013?
Provide a succinct answer. 0.8. What is the ratio of the % of GDP of Haiti in 2009 to that in 2010?
Offer a very short reply. 1.08. What is the ratio of the % of GDP of Kosovo in 2009 to that in 2010?
Provide a succinct answer. 0.94. What is the ratio of the % of GDP in Trinidad and Tobago in 2009 to that in 2010?
Your response must be concise. 1.12. What is the ratio of the % of GDP in Haiti in 2009 to that in 2011?
Offer a very short reply. 0.99. What is the ratio of the % of GDP in Korea (Republic) in 2009 to that in 2011?
Give a very brief answer. 0.86. What is the ratio of the % of GDP in Kosovo in 2009 to that in 2011?
Offer a terse response. 0.92. What is the ratio of the % of GDP in Trinidad and Tobago in 2009 to that in 2011?
Give a very brief answer. 1.12. What is the ratio of the % of GDP in Haiti in 2009 to that in 2012?
Provide a short and direct response. 0.93. What is the ratio of the % of GDP in Korea (Republic) in 2009 to that in 2012?
Provide a short and direct response. 0.92. What is the ratio of the % of GDP in Kosovo in 2009 to that in 2012?
Keep it short and to the point. 1.08. What is the ratio of the % of GDP of Trinidad and Tobago in 2009 to that in 2012?
Offer a very short reply. 1.12. What is the ratio of the % of GDP in Haiti in 2009 to that in 2013?
Offer a terse response. 0.91. What is the ratio of the % of GDP in Korea (Republic) in 2009 to that in 2013?
Your response must be concise. 0.98. What is the ratio of the % of GDP of Kosovo in 2009 to that in 2013?
Your answer should be compact. 1.13. What is the ratio of the % of GDP of Trinidad and Tobago in 2009 to that in 2013?
Provide a short and direct response. 1.12. What is the ratio of the % of GDP of Haiti in 2010 to that in 2011?
Give a very brief answer. 0.91. What is the ratio of the % of GDP of Korea (Republic) in 2010 to that in 2011?
Offer a terse response. 0.97. What is the ratio of the % of GDP of Haiti in 2010 to that in 2012?
Keep it short and to the point. 0.86. What is the ratio of the % of GDP of Korea (Republic) in 2010 to that in 2012?
Ensure brevity in your answer.  1.03. What is the ratio of the % of GDP in Kosovo in 2010 to that in 2012?
Ensure brevity in your answer.  1.14. What is the ratio of the % of GDP of Haiti in 2010 to that in 2013?
Offer a very short reply. 0.85. What is the ratio of the % of GDP in Korea (Republic) in 2010 to that in 2013?
Give a very brief answer. 1.1. What is the ratio of the % of GDP in Kosovo in 2010 to that in 2013?
Offer a terse response. 1.19. What is the ratio of the % of GDP in Trinidad and Tobago in 2010 to that in 2013?
Your answer should be compact. 1. What is the ratio of the % of GDP of Haiti in 2011 to that in 2012?
Your response must be concise. 0.94. What is the ratio of the % of GDP of Korea (Republic) in 2011 to that in 2012?
Keep it short and to the point. 1.06. What is the ratio of the % of GDP of Kosovo in 2011 to that in 2012?
Make the answer very short. 1.17. What is the ratio of the % of GDP in Trinidad and Tobago in 2011 to that in 2012?
Provide a short and direct response. 1. What is the ratio of the % of GDP in Haiti in 2011 to that in 2013?
Provide a succinct answer. 0.93. What is the ratio of the % of GDP in Korea (Republic) in 2011 to that in 2013?
Your answer should be compact. 1.13. What is the ratio of the % of GDP of Kosovo in 2011 to that in 2013?
Keep it short and to the point. 1.23. What is the ratio of the % of GDP of Haiti in 2012 to that in 2013?
Your answer should be very brief. 0.98. What is the ratio of the % of GDP in Korea (Republic) in 2012 to that in 2013?
Offer a terse response. 1.07. What is the ratio of the % of GDP in Kosovo in 2012 to that in 2013?
Make the answer very short. 1.05. What is the difference between the highest and the second highest % of GDP in Haiti?
Your response must be concise. 0.42. What is the difference between the highest and the second highest % of GDP in Korea (Republic)?
Your response must be concise. 0.06. What is the difference between the highest and the second highest % of GDP in Kosovo?
Give a very brief answer. 0.95. What is the difference between the highest and the second highest % of GDP of Trinidad and Tobago?
Make the answer very short. 0.18. What is the difference between the highest and the lowest % of GDP in Haiti?
Provide a short and direct response. 5.07. What is the difference between the highest and the lowest % of GDP in Korea (Republic)?
Your answer should be very brief. 4.55. What is the difference between the highest and the lowest % of GDP in Kosovo?
Provide a succinct answer. 8.9. What is the difference between the highest and the lowest % of GDP in Trinidad and Tobago?
Ensure brevity in your answer.  4.57. 